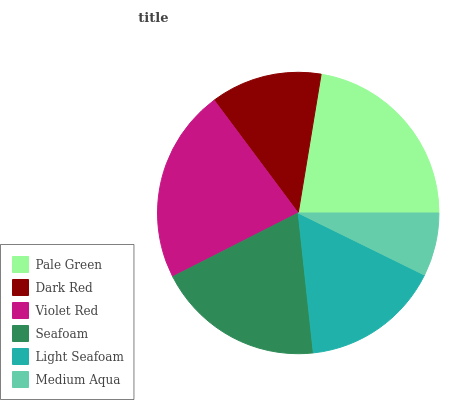Is Medium Aqua the minimum?
Answer yes or no. Yes. Is Pale Green the maximum?
Answer yes or no. Yes. Is Dark Red the minimum?
Answer yes or no. No. Is Dark Red the maximum?
Answer yes or no. No. Is Pale Green greater than Dark Red?
Answer yes or no. Yes. Is Dark Red less than Pale Green?
Answer yes or no. Yes. Is Dark Red greater than Pale Green?
Answer yes or no. No. Is Pale Green less than Dark Red?
Answer yes or no. No. Is Seafoam the high median?
Answer yes or no. Yes. Is Light Seafoam the low median?
Answer yes or no. Yes. Is Violet Red the high median?
Answer yes or no. No. Is Pale Green the low median?
Answer yes or no. No. 